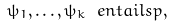<formula> <loc_0><loc_0><loc_500><loc_500>\psi _ { 1 } , \dots , \psi _ { k } \ e n t a i l s p ,</formula> 